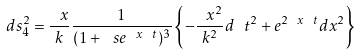Convert formula to latex. <formula><loc_0><loc_0><loc_500><loc_500>d s ^ { 2 } _ { 4 } = \frac { \ x } { k } \frac { 1 } { ( 1 + \ s e ^ { \ x \ t } ) ^ { 3 } } \left \{ - \frac { \ x ^ { 2 } } { k ^ { 2 } } d \ t ^ { 2 } + e ^ { 2 \ x \ t } d { x } ^ { 2 } \right \}</formula> 